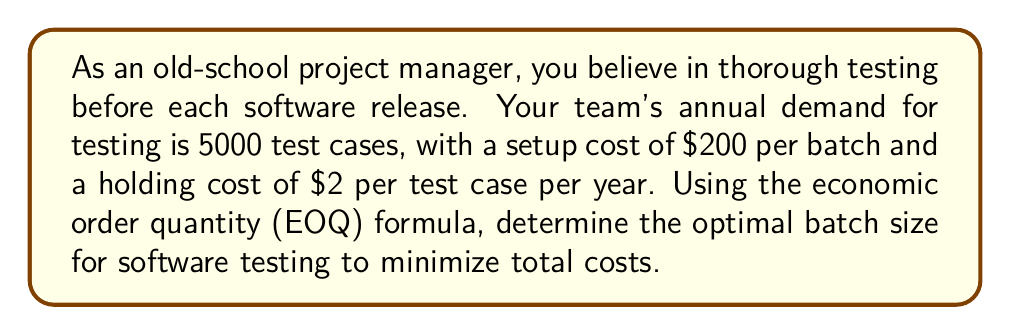Provide a solution to this math problem. To solve this problem, we'll use the Economic Order Quantity (EOQ) formula:

$$EOQ = \sqrt{\frac{2DS}{H}}$$

Where:
$D$ = Annual demand
$S$ = Setup cost per batch
$H$ = Holding cost per unit per year

Given:
$D = 5000$ test cases
$S = \$200$ per batch
$H = \$2$ per test case per year

Step 1: Substitute the values into the EOQ formula:

$$EOQ = \sqrt{\frac{2 \cdot 5000 \cdot 200}{2}}$$

Step 2: Simplify the expression under the square root:

$$EOQ = \sqrt{\frac{2,000,000}{2}} = \sqrt{1,000,000}$$

Step 3: Calculate the square root:

$$EOQ = 1000$$

Therefore, the optimal batch size for software testing is 1000 test cases.
Answer: 1000 test cases 